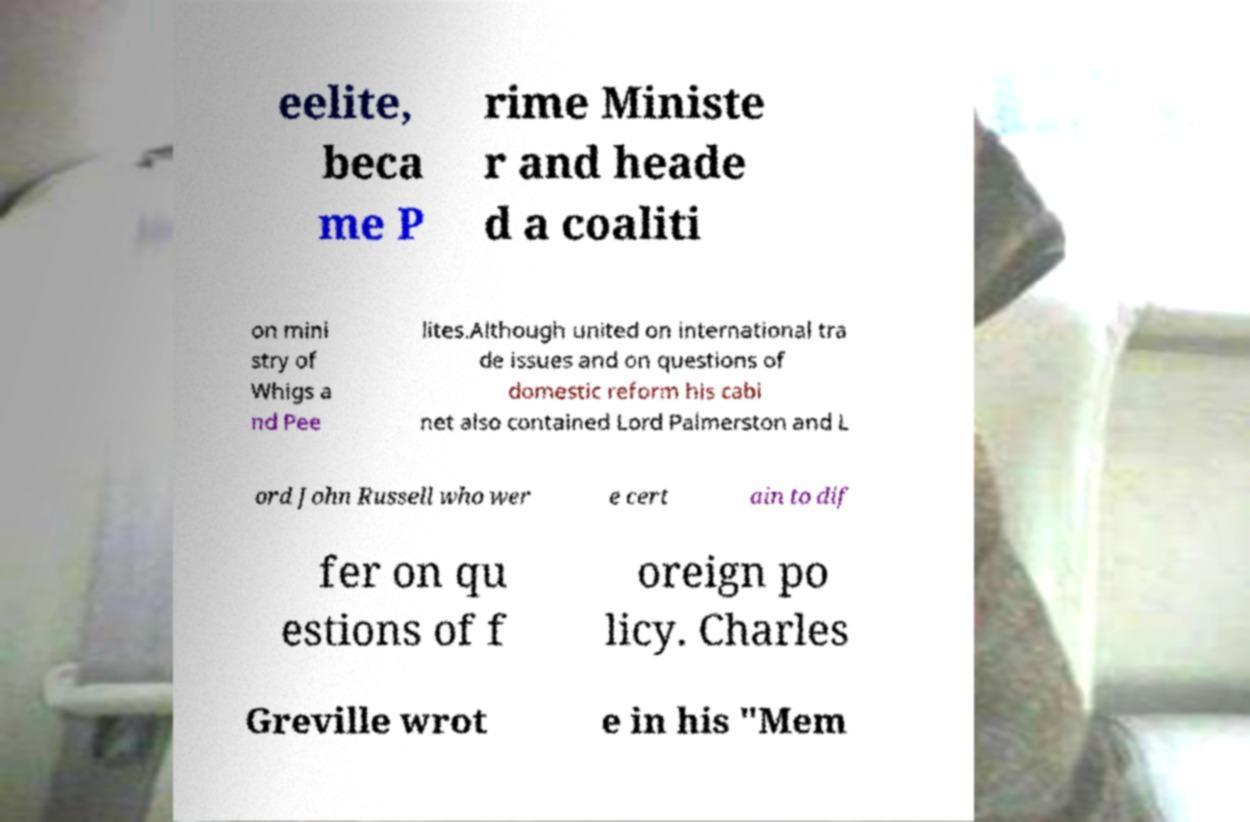Please identify and transcribe the text found in this image. eelite, beca me P rime Ministe r and heade d a coaliti on mini stry of Whigs a nd Pee lites.Although united on international tra de issues and on questions of domestic reform his cabi net also contained Lord Palmerston and L ord John Russell who wer e cert ain to dif fer on qu estions of f oreign po licy. Charles Greville wrot e in his "Mem 